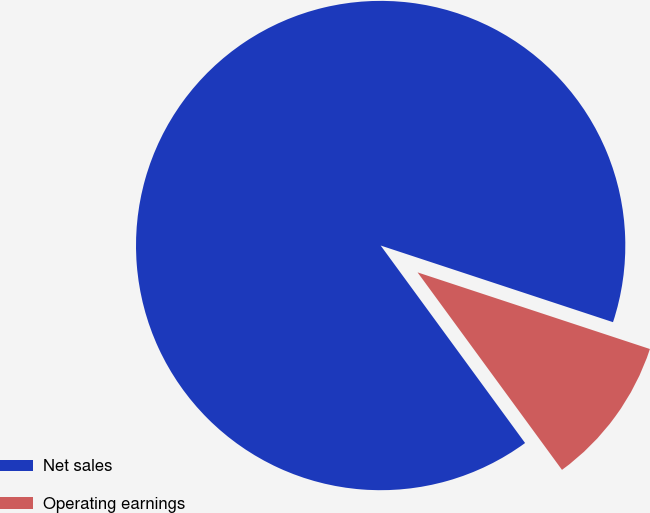<chart> <loc_0><loc_0><loc_500><loc_500><pie_chart><fcel>Net sales<fcel>Operating earnings<nl><fcel>90.12%<fcel>9.88%<nl></chart> 